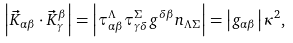<formula> <loc_0><loc_0><loc_500><loc_500>\left | \vec { K } _ { \alpha \beta } \cdot \vec { K } _ { \gamma } ^ { \beta } \right | = \left | \tau _ { \alpha \beta } ^ { \Lambda } \tau _ { \gamma \delta } ^ { \Sigma } g ^ { \delta \beta } n _ { \Lambda \Sigma } \right | = \left | g _ { \alpha \beta } \right | \kappa ^ { 2 } ,</formula> 